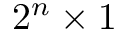<formula> <loc_0><loc_0><loc_500><loc_500>2 ^ { n } \times 1</formula> 